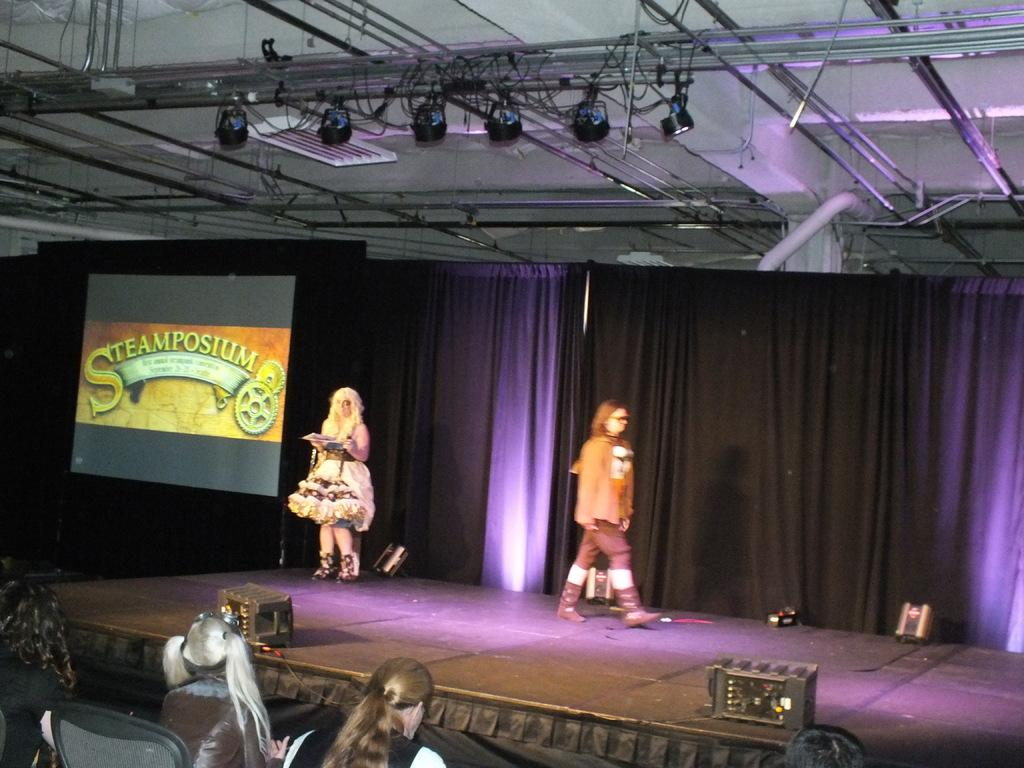What is happening in the foreground of the image? There are people sitting in the foreground of the image. What is happening on the stage in the image? There are people on the stage in the image. What can be seen in the background of the image? There are curtains, a screen, and spotlights in the background of the image. How many houses are visible in the image? There are no houses visible in the image. What type of yarn is being used by the people on the stage? There is no yarn present in the image; the people on the stage are not using any yarn. 